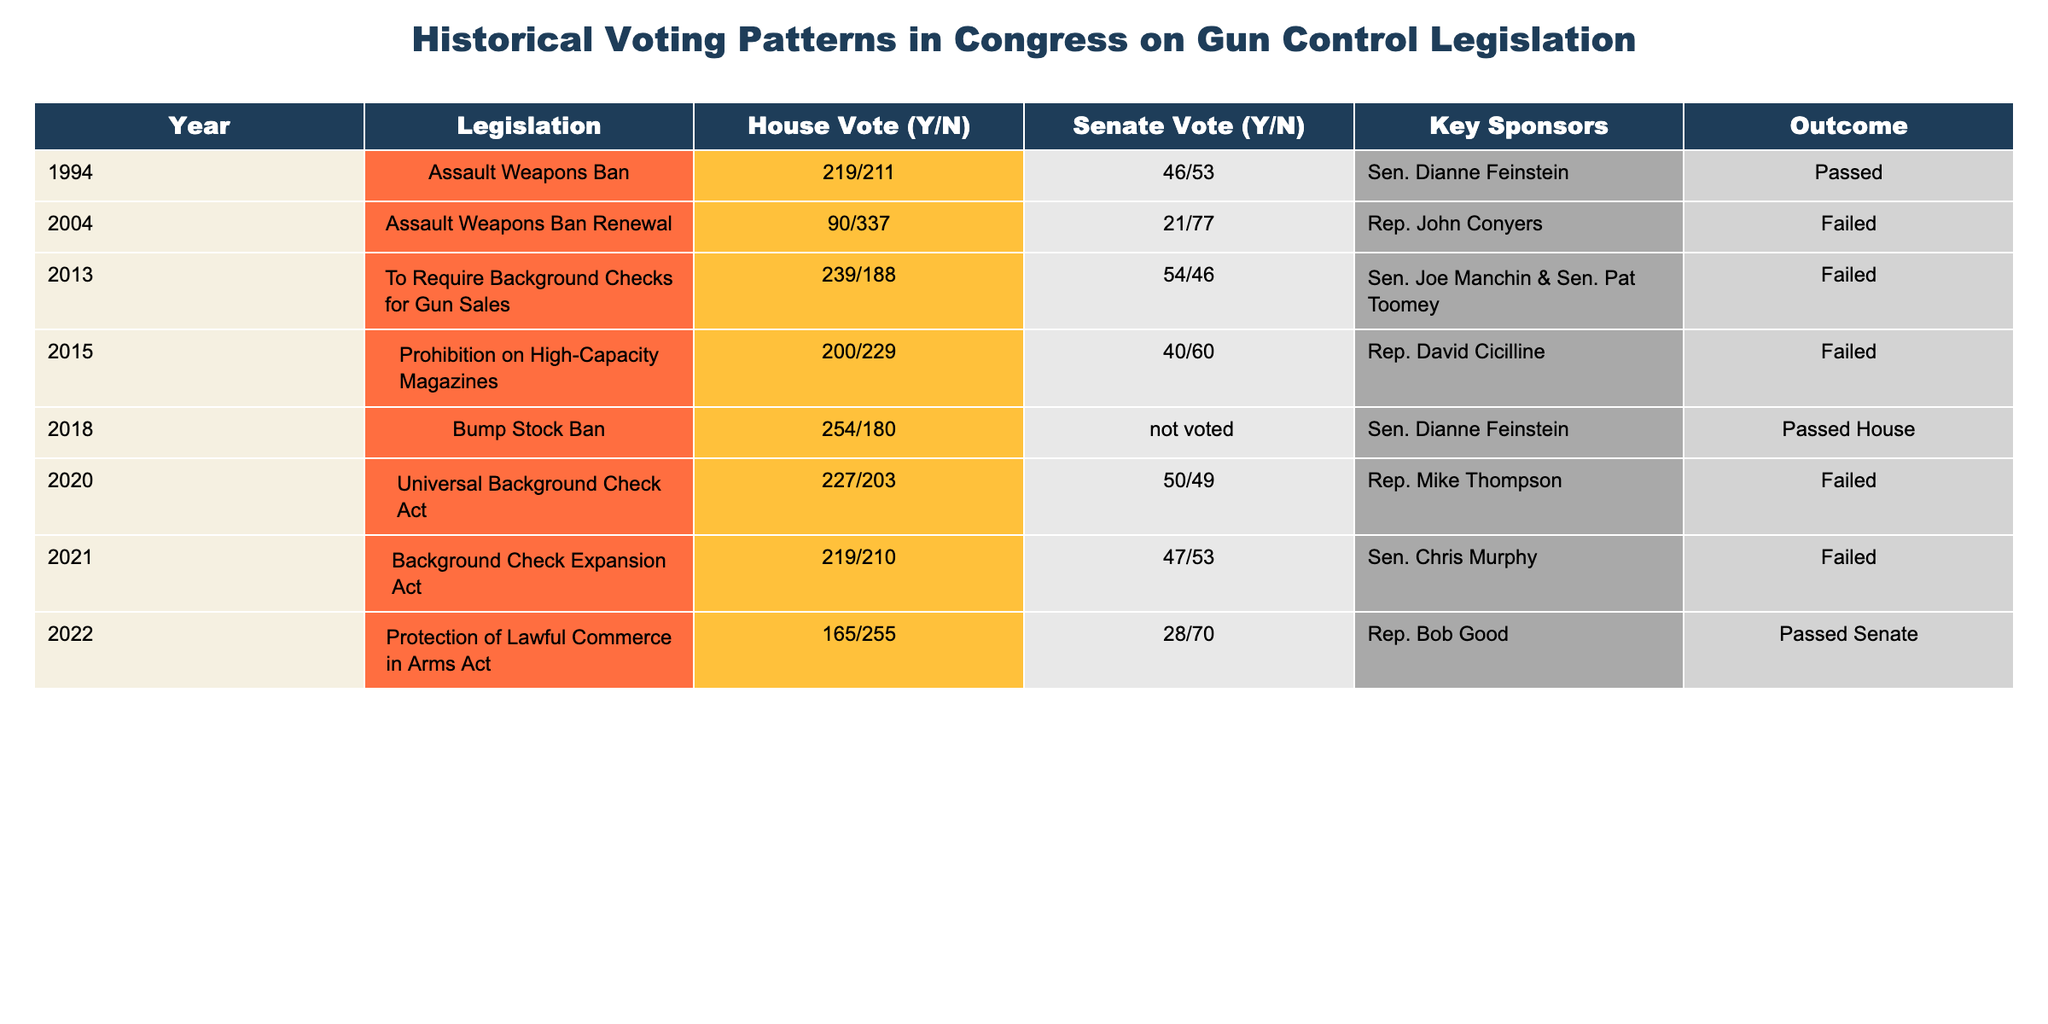What year did the Assault Weapons Ban pass in Congress? The table shows that the Assault Weapons Ban was passed in 1994, as indicated under the Outcome column for that year.
Answer: 1994 What was the vote outcome for the 2020 Universal Background Check Act? According to the table, the Universal Background Check Act was marked as Failed in the Outcome column.
Answer: Failed How many total votes were in favor of the Assault Weapons Ban Renewal in 2004? The table shows that in 2004, the vote was 90 in favor and 337 against for the Assault Weapons Ban Renewal, which sums to a total of 90 votes for the legislation.
Answer: 90 Which legislation had the highest number of "Yes" votes in the House? The table reveals that the Bump Stock Ban in 2018 had 254 "Yes" votes in the House, which is higher than any other legislation listed.
Answer: Bump Stock Ban How many total legislation attempts are listed in the table? By counting the number of rows of legislation, we find there are 8 distinct pieces of legislation listed in total.
Answer: 8 Did the Protection of Lawful Commerce in Arms Act pass in the House? The table indicates that the Protection of Lawful Commerce in Arms Act voted 165 "Yes" and 255 "No" in the House, and was passed in the Senate, but it does not specify it passed in the House.
Answer: No Which legislation had a joint sponsorship by both a Democrat and a Republican senator? The 2013 legislation, to Require Background Checks for Gun Sales, had joint sponsorship by Sen. Joe Manchin (Democrat) and Sen. Pat Toomey (Republican), as indicated in the Key Sponsors column.
Answer: 2013 Background Checks Act What is the difference in the number of "Yes" votes between the 2013 and 2015 gun control legislations? The 2013 measure had 239 "Yes" votes, while the 2015 measure had 200 "Yes" votes. Calculating the difference results in 239 - 200 = 39.
Answer: 39 How many attempts to pass gun control legislation in Congress were ultimately successful? Looking over the outcome column, only the Assault Weapons Ban in 1994 and the Bump Stock Ban attempt in 2018 were passed, resulting in a total of 2 successful attempts.
Answer: 2 Which year showed the most failure votes for gun control legislation? The 2004 Assault Weapons Ban Renewal had 337 "No" votes, which is the highest number of failure votes listed in the table, indicating the most significant opposition.
Answer: 2004 